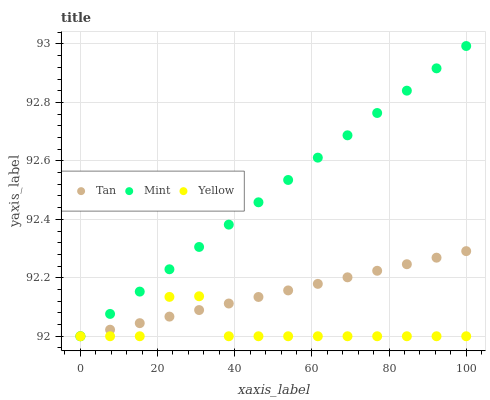Does Yellow have the minimum area under the curve?
Answer yes or no. Yes. Does Mint have the maximum area under the curve?
Answer yes or no. Yes. Does Mint have the minimum area under the curve?
Answer yes or no. No. Does Yellow have the maximum area under the curve?
Answer yes or no. No. Is Tan the smoothest?
Answer yes or no. Yes. Is Yellow the roughest?
Answer yes or no. Yes. Is Mint the smoothest?
Answer yes or no. No. Is Mint the roughest?
Answer yes or no. No. Does Tan have the lowest value?
Answer yes or no. Yes. Does Mint have the highest value?
Answer yes or no. Yes. Does Yellow have the highest value?
Answer yes or no. No. Does Mint intersect Yellow?
Answer yes or no. Yes. Is Mint less than Yellow?
Answer yes or no. No. Is Mint greater than Yellow?
Answer yes or no. No. 